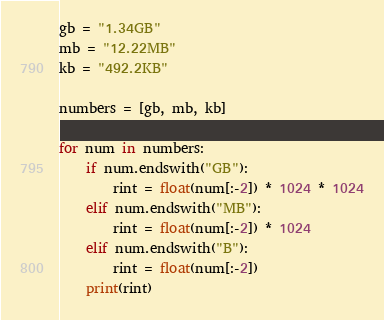<code> <loc_0><loc_0><loc_500><loc_500><_Python_>
gb = "1.34GB"
mb = "12.22MB"
kb = "492.2KB"

numbers = [gb, mb, kb]

for num in numbers:
    if num.endswith("GB"):
        rint = float(num[:-2]) * 1024 * 1024
    elif num.endswith("MB"):
        rint = float(num[:-2]) * 1024
    elif num.endswith("B"):
        rint = float(num[:-2])
    print(rint)</code> 